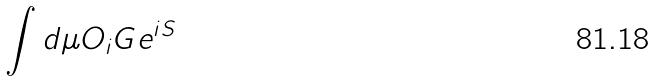<formula> <loc_0><loc_0><loc_500><loc_500>\int d \mu O _ { i } G e ^ { i S }</formula> 